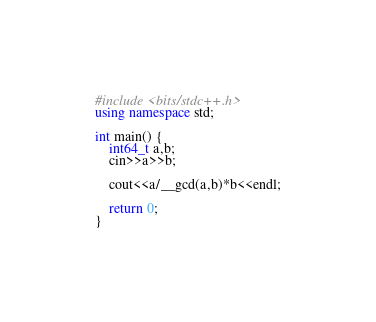<code> <loc_0><loc_0><loc_500><loc_500><_C++_>#include <bits/stdc++.h>
using namespace std;

int main() {
    int64_t a,b;
    cin>>a>>b;

    cout<<a/__gcd(a,b)*b<<endl;

    return 0;
}</code> 